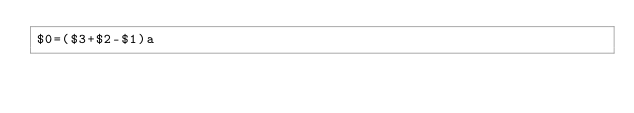<code> <loc_0><loc_0><loc_500><loc_500><_Awk_>$0=($3+$2-$1)a</code> 